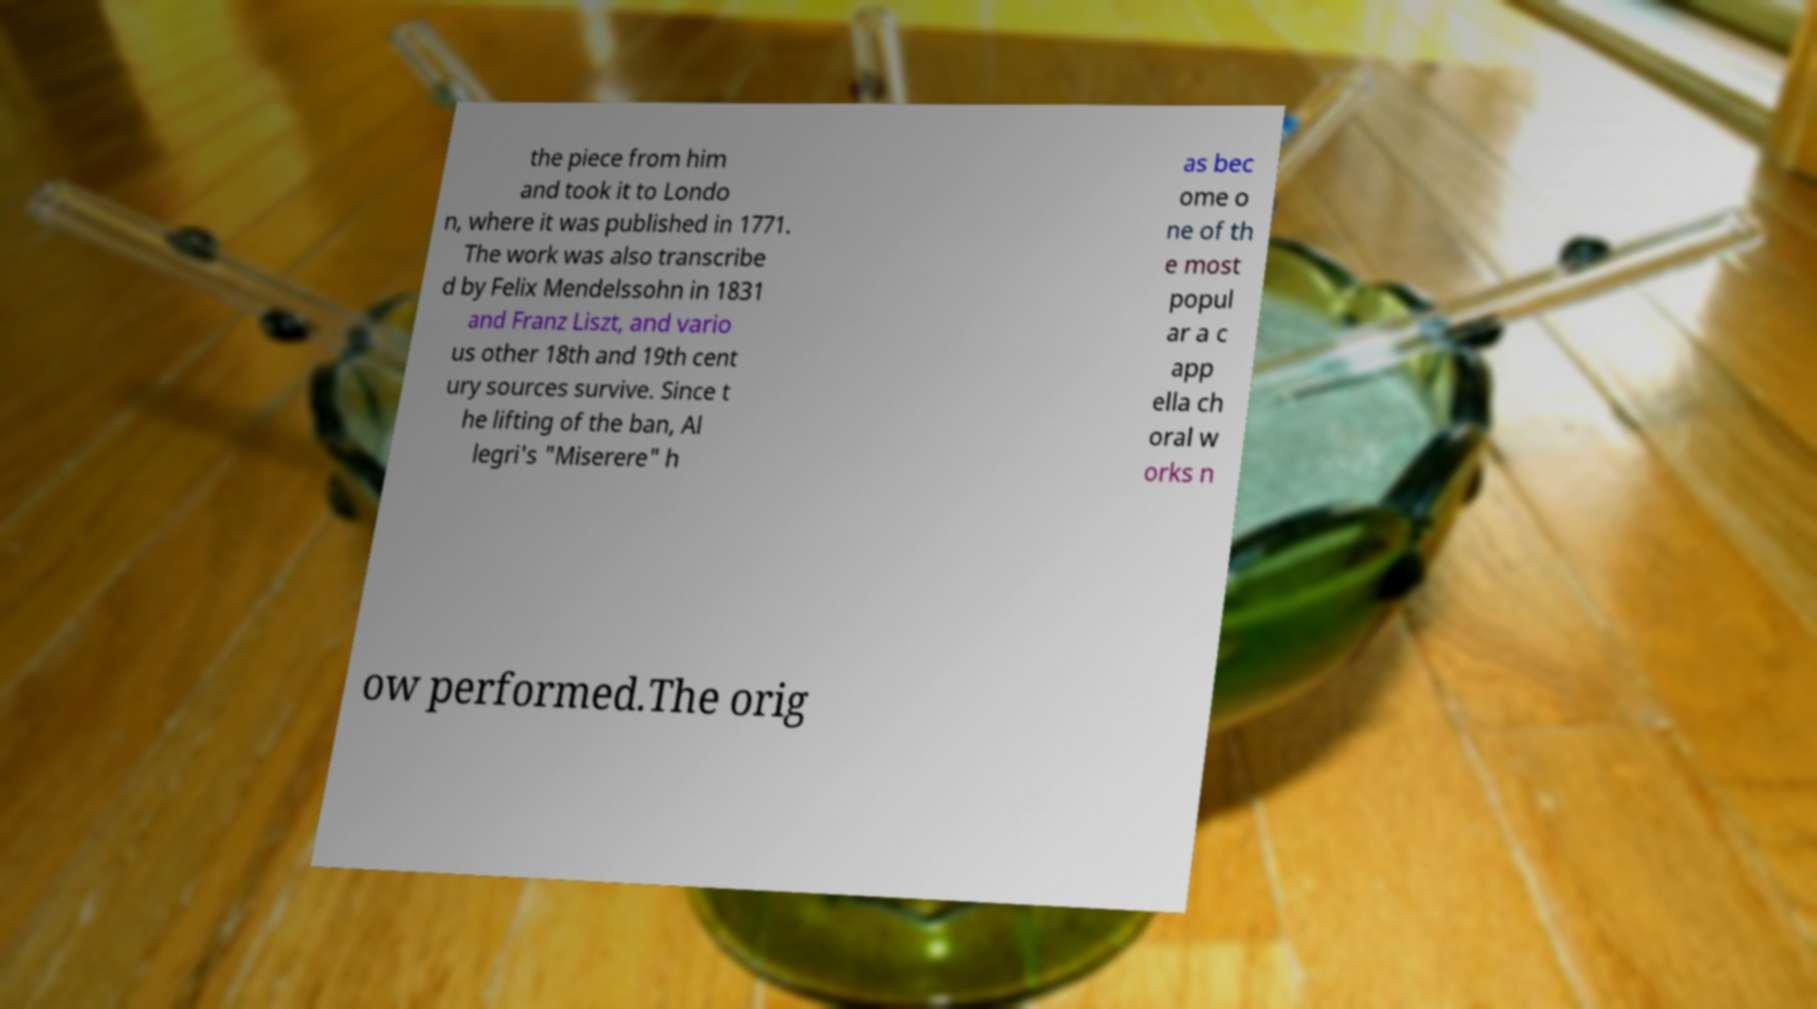Can you accurately transcribe the text from the provided image for me? the piece from him and took it to Londo n, where it was published in 1771. The work was also transcribe d by Felix Mendelssohn in 1831 and Franz Liszt, and vario us other 18th and 19th cent ury sources survive. Since t he lifting of the ban, Al legri's "Miserere" h as bec ome o ne of th e most popul ar a c app ella ch oral w orks n ow performed.The orig 